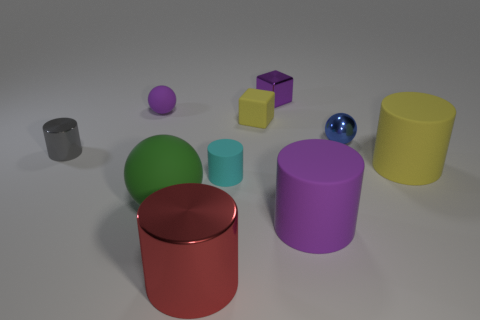Subtract all blue balls. How many balls are left? 2 Subtract 1 cubes. How many cubes are left? 1 Subtract all blue spheres. How many spheres are left? 2 Subtract all cubes. How many objects are left? 8 Subtract all small cylinders. Subtract all tiny purple metallic objects. How many objects are left? 7 Add 3 cyan objects. How many cyan objects are left? 4 Add 7 yellow matte blocks. How many yellow matte blocks exist? 8 Subtract 0 cyan blocks. How many objects are left? 10 Subtract all brown cubes. Subtract all blue cylinders. How many cubes are left? 2 Subtract all red cubes. How many blue balls are left? 1 